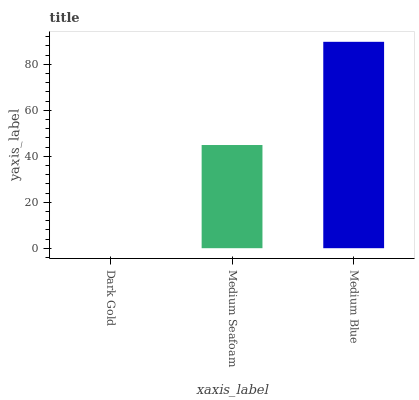Is Dark Gold the minimum?
Answer yes or no. Yes. Is Medium Blue the maximum?
Answer yes or no. Yes. Is Medium Seafoam the minimum?
Answer yes or no. No. Is Medium Seafoam the maximum?
Answer yes or no. No. Is Medium Seafoam greater than Dark Gold?
Answer yes or no. Yes. Is Dark Gold less than Medium Seafoam?
Answer yes or no. Yes. Is Dark Gold greater than Medium Seafoam?
Answer yes or no. No. Is Medium Seafoam less than Dark Gold?
Answer yes or no. No. Is Medium Seafoam the high median?
Answer yes or no. Yes. Is Medium Seafoam the low median?
Answer yes or no. Yes. Is Medium Blue the high median?
Answer yes or no. No. Is Dark Gold the low median?
Answer yes or no. No. 